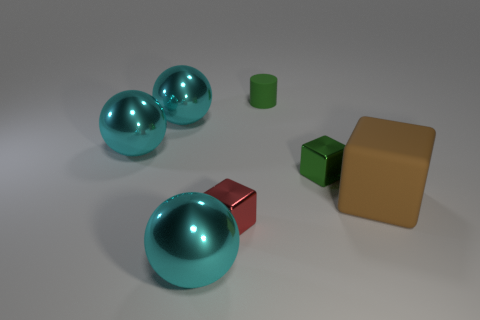How many cyan balls must be subtracted to get 1 cyan balls? 2 Subtract 1 balls. How many balls are left? 2 Subtract all small shiny blocks. How many blocks are left? 1 Add 1 green metallic objects. How many objects exist? 8 Subtract all cubes. How many objects are left? 4 Add 5 shiny objects. How many shiny objects are left? 10 Add 5 tiny brown matte cylinders. How many tiny brown matte cylinders exist? 5 Subtract 0 purple spheres. How many objects are left? 7 Subtract all big spheres. Subtract all tiny green things. How many objects are left? 2 